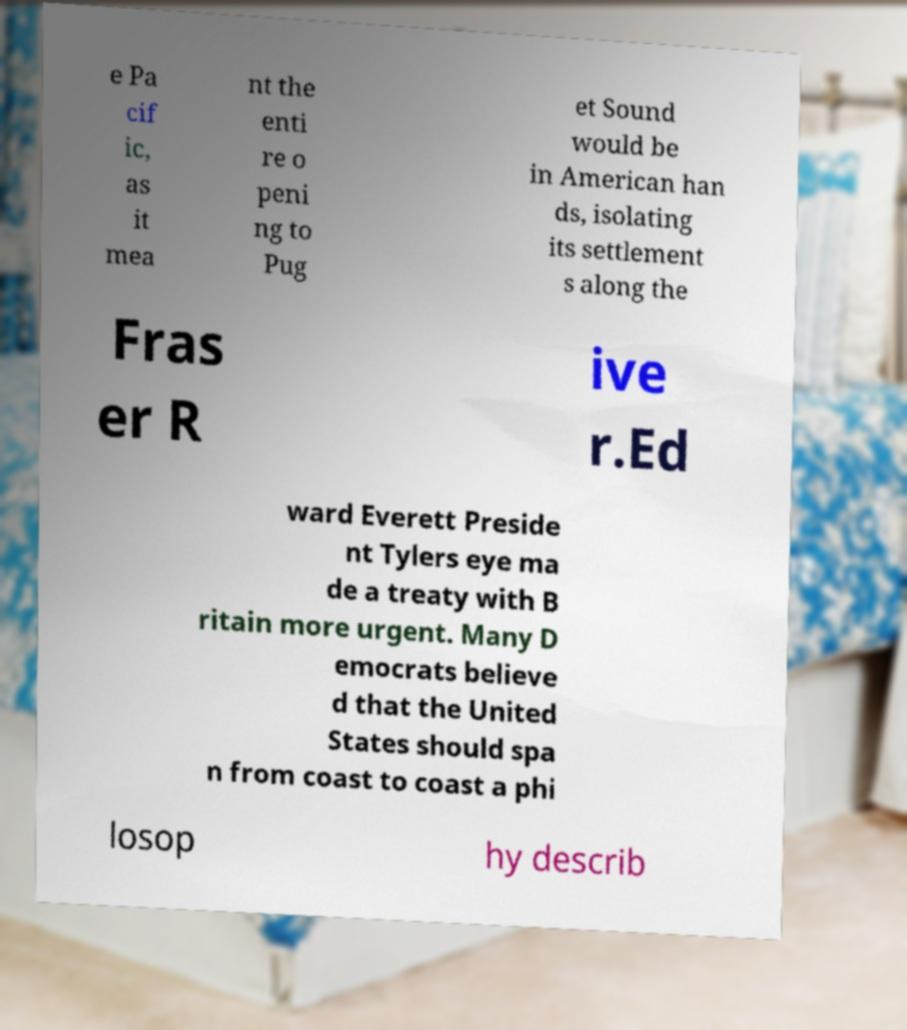What messages or text are displayed in this image? I need them in a readable, typed format. e Pa cif ic, as it mea nt the enti re o peni ng to Pug et Sound would be in American han ds, isolating its settlement s along the Fras er R ive r.Ed ward Everett Preside nt Tylers eye ma de a treaty with B ritain more urgent. Many D emocrats believe d that the United States should spa n from coast to coast a phi losop hy describ 